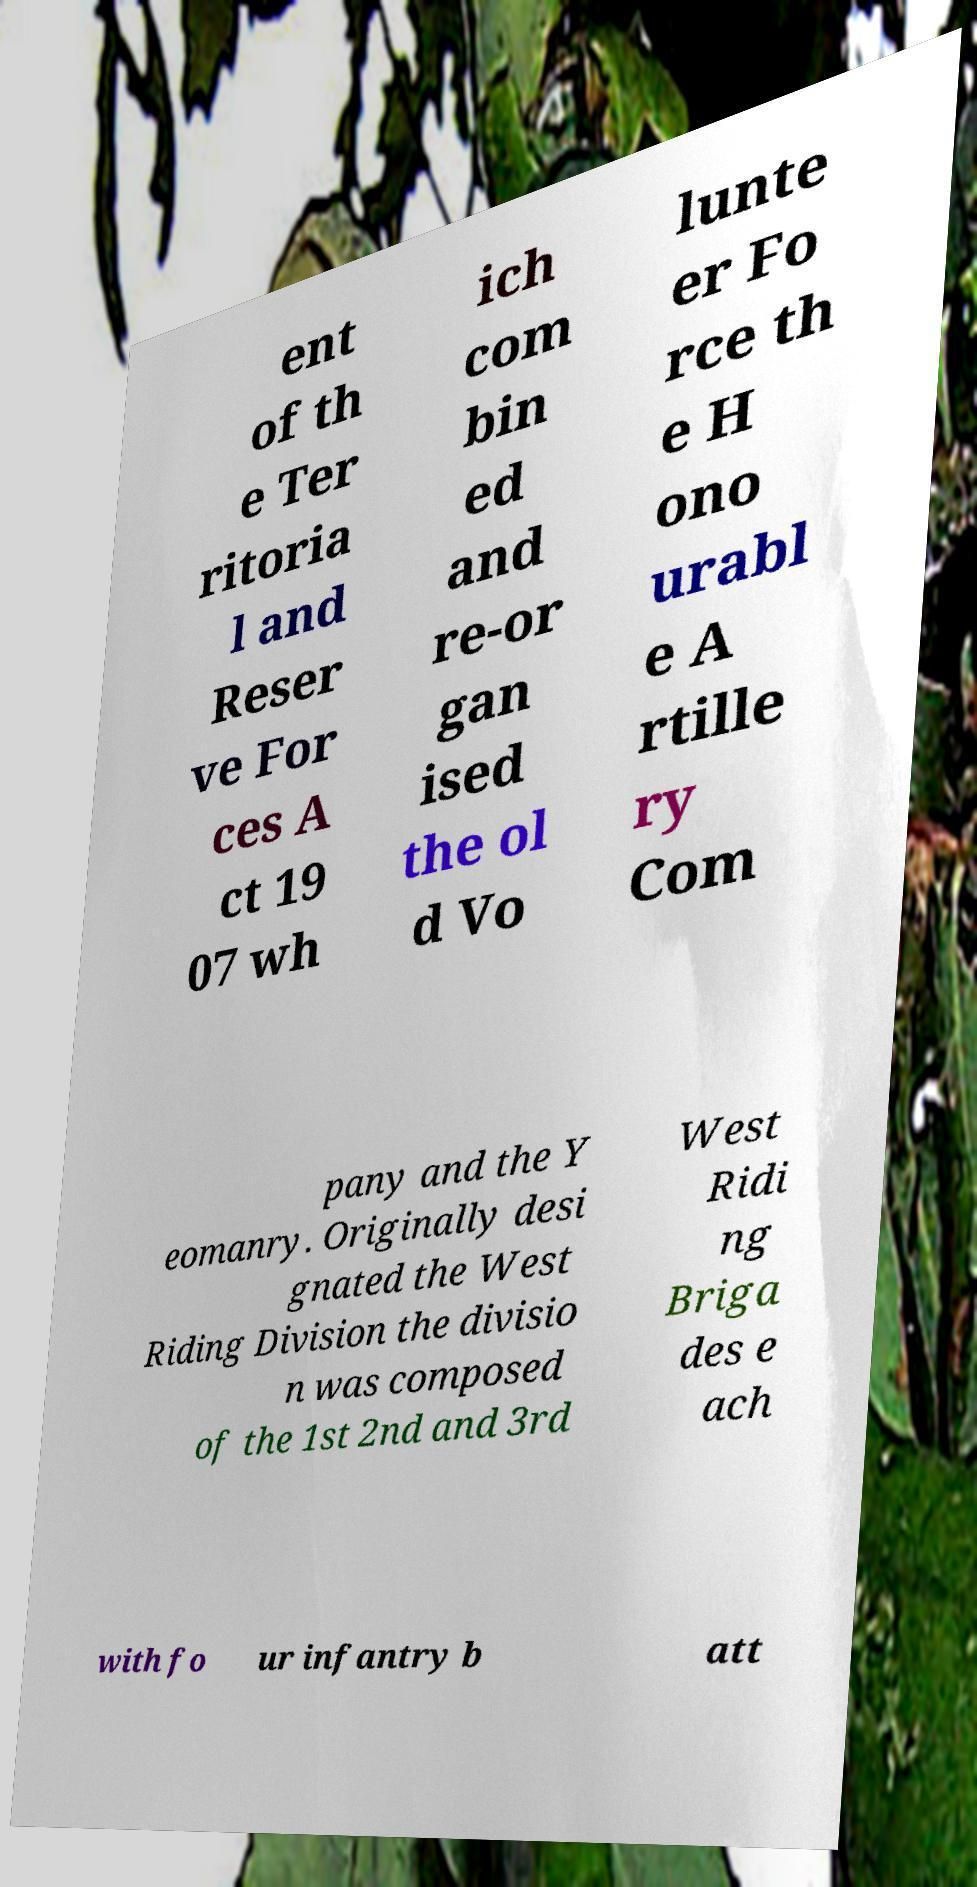Can you accurately transcribe the text from the provided image for me? ent of th e Ter ritoria l and Reser ve For ces A ct 19 07 wh ich com bin ed and re-or gan ised the ol d Vo lunte er Fo rce th e H ono urabl e A rtille ry Com pany and the Y eomanry. Originally desi gnated the West Riding Division the divisio n was composed of the 1st 2nd and 3rd West Ridi ng Briga des e ach with fo ur infantry b att 